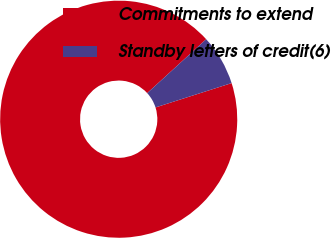Convert chart to OTSL. <chart><loc_0><loc_0><loc_500><loc_500><pie_chart><fcel>Commitments to extend<fcel>Standby letters of credit(6)<nl><fcel>93.14%<fcel>6.86%<nl></chart> 